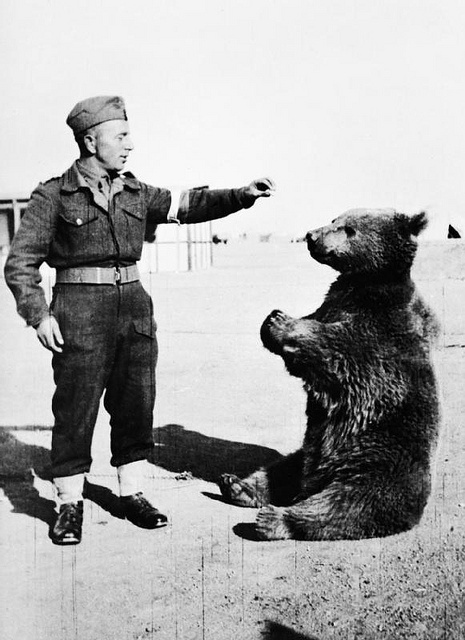Describe the objects in this image and their specific colors. I can see bear in white, black, gray, darkgray, and lightgray tones and people in white, black, gray, lightgray, and darkgray tones in this image. 